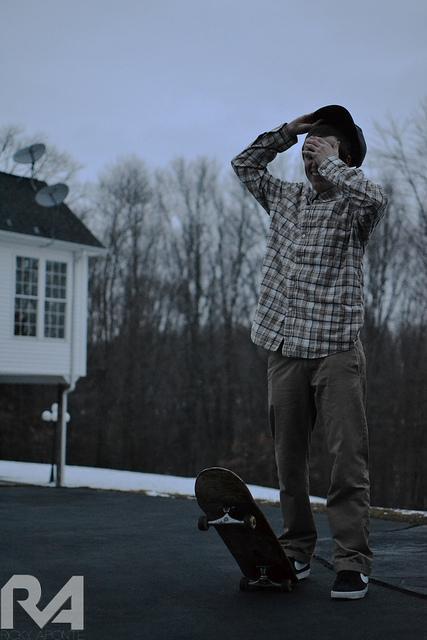How many satellite dishes are on the house?
Give a very brief answer. 2. How many children are in this image?
Give a very brief answer. 1. How many windows are in the building?
Give a very brief answer. 2. 